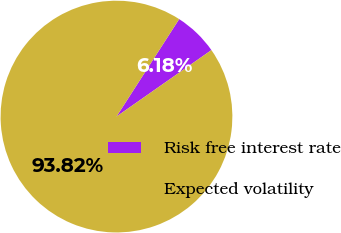<chart> <loc_0><loc_0><loc_500><loc_500><pie_chart><fcel>Risk free interest rate<fcel>Expected volatility<nl><fcel>6.18%<fcel>93.82%<nl></chart> 